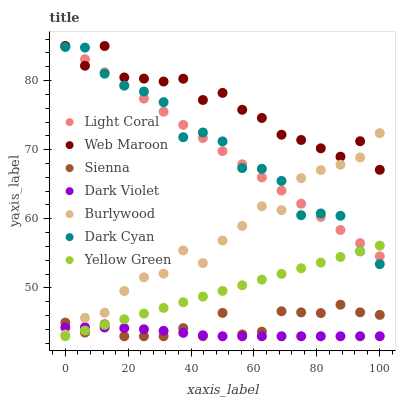Does Dark Violet have the minimum area under the curve?
Answer yes or no. Yes. Does Web Maroon have the maximum area under the curve?
Answer yes or no. Yes. Does Yellow Green have the minimum area under the curve?
Answer yes or no. No. Does Yellow Green have the maximum area under the curve?
Answer yes or no. No. Is Yellow Green the smoothest?
Answer yes or no. Yes. Is Web Maroon the roughest?
Answer yes or no. Yes. Is Burlywood the smoothest?
Answer yes or no. No. Is Burlywood the roughest?
Answer yes or no. No. Does Sienna have the lowest value?
Answer yes or no. Yes. Does Burlywood have the lowest value?
Answer yes or no. No. Does Light Coral have the highest value?
Answer yes or no. Yes. Does Yellow Green have the highest value?
Answer yes or no. No. Is Sienna less than Dark Cyan?
Answer yes or no. Yes. Is Light Coral greater than Dark Violet?
Answer yes or no. Yes. Does Dark Violet intersect Burlywood?
Answer yes or no. Yes. Is Dark Violet less than Burlywood?
Answer yes or no. No. Is Dark Violet greater than Burlywood?
Answer yes or no. No. Does Sienna intersect Dark Cyan?
Answer yes or no. No. 